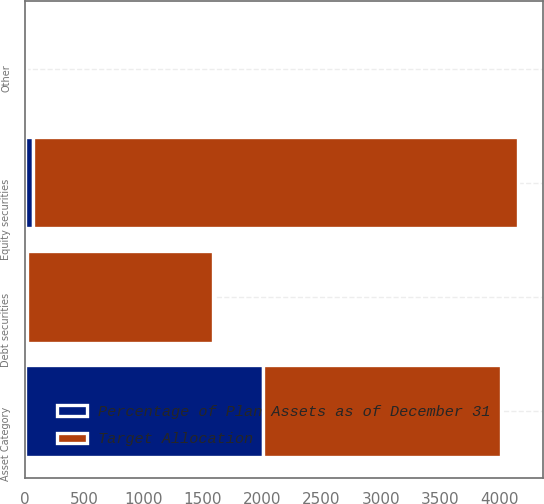Convert chart to OTSL. <chart><loc_0><loc_0><loc_500><loc_500><stacked_bar_chart><ecel><fcel>Asset Category<fcel>Equity securities<fcel>Debt securities<fcel>Other<nl><fcel>Target Allocation<fcel>2006<fcel>4085<fcel>1560<fcel>10<nl><fcel>Percentage of Plan Assets as of December 31<fcel>2005<fcel>74<fcel>24<fcel>2<nl></chart> 